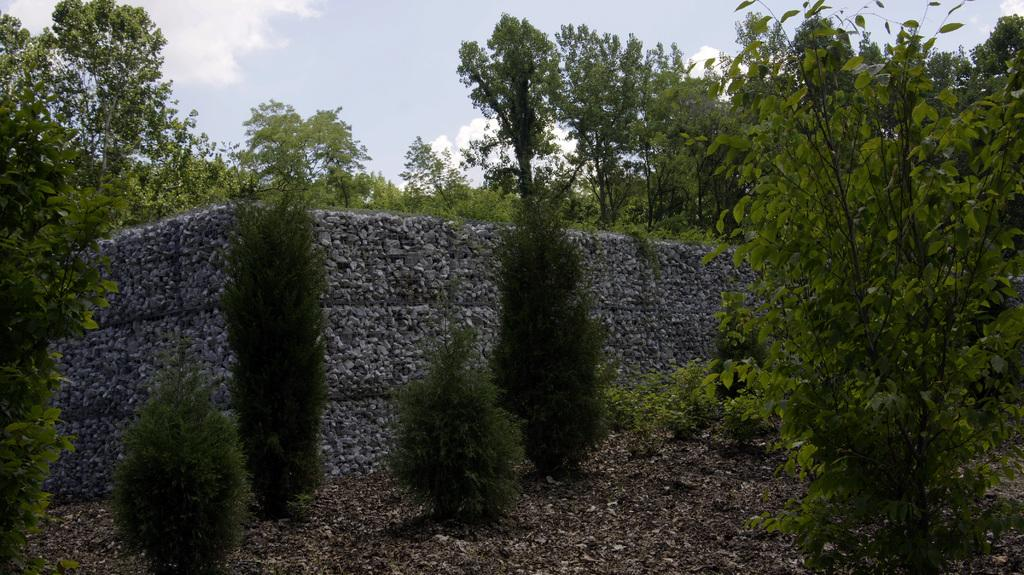What can be seen in the sky in the image? The sky is visible in the image. What type of vegetation is present in the image? There are trees in the image. What geological feature can be seen in the image? There is a rock in the image. Can you see a giraffe drinking from the river in the image? There is no giraffe or river present in the image. What type of adjustment is being made to the rock in the image? There is no adjustment being made to the rock in the image; it is a stationary geological feature. 